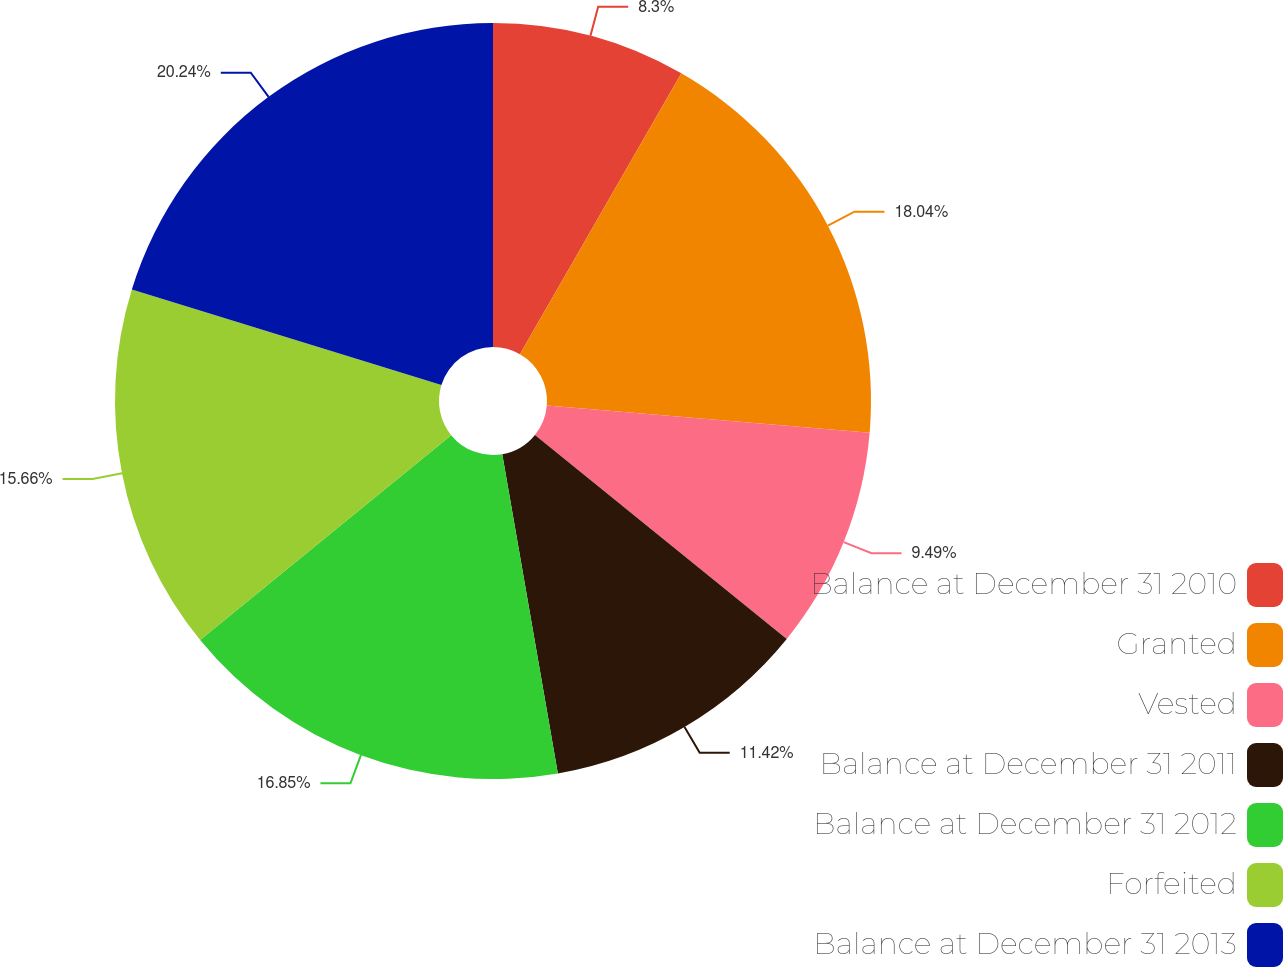Convert chart to OTSL. <chart><loc_0><loc_0><loc_500><loc_500><pie_chart><fcel>Balance at December 31 2010<fcel>Granted<fcel>Vested<fcel>Balance at December 31 2011<fcel>Balance at December 31 2012<fcel>Forfeited<fcel>Balance at December 31 2013<nl><fcel>8.3%<fcel>18.04%<fcel>9.49%<fcel>11.42%<fcel>16.85%<fcel>15.66%<fcel>20.23%<nl></chart> 